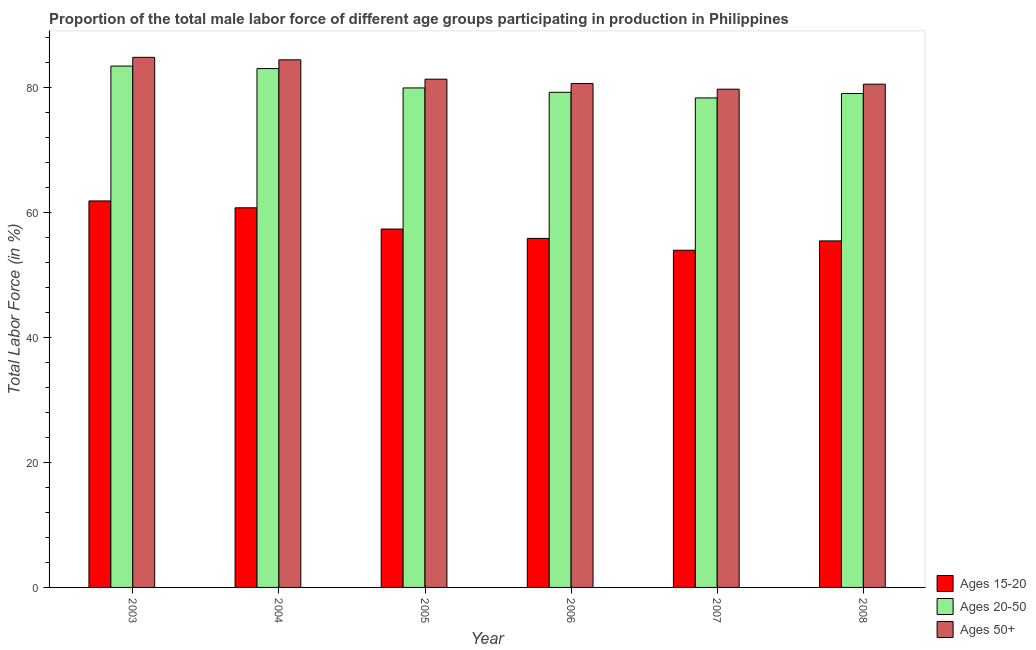How many different coloured bars are there?
Keep it short and to the point. 3. How many groups of bars are there?
Your response must be concise. 6. Are the number of bars on each tick of the X-axis equal?
Keep it short and to the point. Yes. How many bars are there on the 5th tick from the left?
Your response must be concise. 3. What is the label of the 3rd group of bars from the left?
Provide a short and direct response. 2005. In how many cases, is the number of bars for a given year not equal to the number of legend labels?
Give a very brief answer. 0. What is the percentage of male labor force above age 50 in 2007?
Make the answer very short. 79.8. Across all years, what is the maximum percentage of male labor force within the age group 15-20?
Ensure brevity in your answer.  61.9. Across all years, what is the minimum percentage of male labor force within the age group 20-50?
Make the answer very short. 78.4. In which year was the percentage of male labor force within the age group 15-20 maximum?
Offer a terse response. 2003. In which year was the percentage of male labor force above age 50 minimum?
Your answer should be very brief. 2007. What is the total percentage of male labor force within the age group 15-20 in the graph?
Offer a terse response. 345.5. What is the difference between the percentage of male labor force within the age group 15-20 in 2006 and that in 2007?
Your answer should be very brief. 1.9. What is the difference between the percentage of male labor force within the age group 15-20 in 2007 and the percentage of male labor force above age 50 in 2008?
Give a very brief answer. -1.5. What is the average percentage of male labor force within the age group 15-20 per year?
Your answer should be very brief. 57.58. In the year 2004, what is the difference between the percentage of male labor force within the age group 15-20 and percentage of male labor force within the age group 20-50?
Make the answer very short. 0. What is the ratio of the percentage of male labor force within the age group 15-20 in 2003 to that in 2005?
Provide a short and direct response. 1.08. Is the percentage of male labor force above age 50 in 2005 less than that in 2006?
Offer a very short reply. No. What is the difference between the highest and the second highest percentage of male labor force within the age group 15-20?
Your answer should be compact. 1.1. What is the difference between the highest and the lowest percentage of male labor force within the age group 15-20?
Provide a short and direct response. 7.9. Is the sum of the percentage of male labor force within the age group 15-20 in 2004 and 2005 greater than the maximum percentage of male labor force above age 50 across all years?
Your answer should be very brief. Yes. What does the 2nd bar from the left in 2006 represents?
Offer a very short reply. Ages 20-50. What does the 2nd bar from the right in 2007 represents?
Offer a terse response. Ages 20-50. Are all the bars in the graph horizontal?
Provide a short and direct response. No. Are the values on the major ticks of Y-axis written in scientific E-notation?
Offer a very short reply. No. Does the graph contain grids?
Your response must be concise. No. How many legend labels are there?
Give a very brief answer. 3. What is the title of the graph?
Keep it short and to the point. Proportion of the total male labor force of different age groups participating in production in Philippines. Does "Unpaid family workers" appear as one of the legend labels in the graph?
Make the answer very short. No. What is the label or title of the X-axis?
Offer a terse response. Year. What is the label or title of the Y-axis?
Provide a short and direct response. Total Labor Force (in %). What is the Total Labor Force (in %) of Ages 15-20 in 2003?
Your answer should be compact. 61.9. What is the Total Labor Force (in %) in Ages 20-50 in 2003?
Your response must be concise. 83.5. What is the Total Labor Force (in %) in Ages 50+ in 2003?
Keep it short and to the point. 84.9. What is the Total Labor Force (in %) of Ages 15-20 in 2004?
Ensure brevity in your answer.  60.8. What is the Total Labor Force (in %) in Ages 20-50 in 2004?
Keep it short and to the point. 83.1. What is the Total Labor Force (in %) of Ages 50+ in 2004?
Give a very brief answer. 84.5. What is the Total Labor Force (in %) of Ages 15-20 in 2005?
Provide a short and direct response. 57.4. What is the Total Labor Force (in %) of Ages 20-50 in 2005?
Give a very brief answer. 80. What is the Total Labor Force (in %) in Ages 50+ in 2005?
Give a very brief answer. 81.4. What is the Total Labor Force (in %) of Ages 15-20 in 2006?
Provide a short and direct response. 55.9. What is the Total Labor Force (in %) in Ages 20-50 in 2006?
Your answer should be very brief. 79.3. What is the Total Labor Force (in %) of Ages 50+ in 2006?
Your response must be concise. 80.7. What is the Total Labor Force (in %) in Ages 20-50 in 2007?
Keep it short and to the point. 78.4. What is the Total Labor Force (in %) of Ages 50+ in 2007?
Ensure brevity in your answer.  79.8. What is the Total Labor Force (in %) in Ages 15-20 in 2008?
Your answer should be compact. 55.5. What is the Total Labor Force (in %) of Ages 20-50 in 2008?
Give a very brief answer. 79.1. What is the Total Labor Force (in %) in Ages 50+ in 2008?
Give a very brief answer. 80.6. Across all years, what is the maximum Total Labor Force (in %) in Ages 15-20?
Your answer should be very brief. 61.9. Across all years, what is the maximum Total Labor Force (in %) of Ages 20-50?
Keep it short and to the point. 83.5. Across all years, what is the maximum Total Labor Force (in %) in Ages 50+?
Keep it short and to the point. 84.9. Across all years, what is the minimum Total Labor Force (in %) of Ages 20-50?
Offer a terse response. 78.4. Across all years, what is the minimum Total Labor Force (in %) of Ages 50+?
Make the answer very short. 79.8. What is the total Total Labor Force (in %) in Ages 15-20 in the graph?
Your response must be concise. 345.5. What is the total Total Labor Force (in %) in Ages 20-50 in the graph?
Provide a succinct answer. 483.4. What is the total Total Labor Force (in %) in Ages 50+ in the graph?
Offer a very short reply. 491.9. What is the difference between the Total Labor Force (in %) of Ages 50+ in 2003 and that in 2004?
Ensure brevity in your answer.  0.4. What is the difference between the Total Labor Force (in %) of Ages 20-50 in 2003 and that in 2005?
Ensure brevity in your answer.  3.5. What is the difference between the Total Labor Force (in %) of Ages 50+ in 2003 and that in 2005?
Make the answer very short. 3.5. What is the difference between the Total Labor Force (in %) in Ages 15-20 in 2003 and that in 2006?
Give a very brief answer. 6. What is the difference between the Total Labor Force (in %) of Ages 50+ in 2003 and that in 2006?
Your answer should be very brief. 4.2. What is the difference between the Total Labor Force (in %) of Ages 20-50 in 2003 and that in 2007?
Your answer should be very brief. 5.1. What is the difference between the Total Labor Force (in %) in Ages 15-20 in 2003 and that in 2008?
Offer a very short reply. 6.4. What is the difference between the Total Labor Force (in %) in Ages 20-50 in 2004 and that in 2005?
Your answer should be very brief. 3.1. What is the difference between the Total Labor Force (in %) of Ages 15-20 in 2004 and that in 2006?
Make the answer very short. 4.9. What is the difference between the Total Labor Force (in %) in Ages 20-50 in 2004 and that in 2006?
Your answer should be very brief. 3.8. What is the difference between the Total Labor Force (in %) in Ages 50+ in 2004 and that in 2006?
Keep it short and to the point. 3.8. What is the difference between the Total Labor Force (in %) in Ages 15-20 in 2004 and that in 2008?
Ensure brevity in your answer.  5.3. What is the difference between the Total Labor Force (in %) of Ages 20-50 in 2004 and that in 2008?
Provide a short and direct response. 4. What is the difference between the Total Labor Force (in %) in Ages 15-20 in 2005 and that in 2006?
Offer a terse response. 1.5. What is the difference between the Total Labor Force (in %) of Ages 20-50 in 2005 and that in 2006?
Keep it short and to the point. 0.7. What is the difference between the Total Labor Force (in %) in Ages 20-50 in 2005 and that in 2007?
Your answer should be compact. 1.6. What is the difference between the Total Labor Force (in %) of Ages 15-20 in 2005 and that in 2008?
Your answer should be compact. 1.9. What is the difference between the Total Labor Force (in %) in Ages 50+ in 2005 and that in 2008?
Give a very brief answer. 0.8. What is the difference between the Total Labor Force (in %) in Ages 50+ in 2006 and that in 2007?
Make the answer very short. 0.9. What is the difference between the Total Labor Force (in %) in Ages 20-50 in 2006 and that in 2008?
Keep it short and to the point. 0.2. What is the difference between the Total Labor Force (in %) in Ages 50+ in 2006 and that in 2008?
Provide a succinct answer. 0.1. What is the difference between the Total Labor Force (in %) of Ages 50+ in 2007 and that in 2008?
Give a very brief answer. -0.8. What is the difference between the Total Labor Force (in %) of Ages 15-20 in 2003 and the Total Labor Force (in %) of Ages 20-50 in 2004?
Give a very brief answer. -21.2. What is the difference between the Total Labor Force (in %) of Ages 15-20 in 2003 and the Total Labor Force (in %) of Ages 50+ in 2004?
Offer a terse response. -22.6. What is the difference between the Total Labor Force (in %) of Ages 20-50 in 2003 and the Total Labor Force (in %) of Ages 50+ in 2004?
Keep it short and to the point. -1. What is the difference between the Total Labor Force (in %) in Ages 15-20 in 2003 and the Total Labor Force (in %) in Ages 20-50 in 2005?
Make the answer very short. -18.1. What is the difference between the Total Labor Force (in %) of Ages 15-20 in 2003 and the Total Labor Force (in %) of Ages 50+ in 2005?
Ensure brevity in your answer.  -19.5. What is the difference between the Total Labor Force (in %) of Ages 15-20 in 2003 and the Total Labor Force (in %) of Ages 20-50 in 2006?
Ensure brevity in your answer.  -17.4. What is the difference between the Total Labor Force (in %) in Ages 15-20 in 2003 and the Total Labor Force (in %) in Ages 50+ in 2006?
Your answer should be compact. -18.8. What is the difference between the Total Labor Force (in %) of Ages 15-20 in 2003 and the Total Labor Force (in %) of Ages 20-50 in 2007?
Your answer should be very brief. -16.5. What is the difference between the Total Labor Force (in %) of Ages 15-20 in 2003 and the Total Labor Force (in %) of Ages 50+ in 2007?
Your answer should be compact. -17.9. What is the difference between the Total Labor Force (in %) of Ages 20-50 in 2003 and the Total Labor Force (in %) of Ages 50+ in 2007?
Give a very brief answer. 3.7. What is the difference between the Total Labor Force (in %) in Ages 15-20 in 2003 and the Total Labor Force (in %) in Ages 20-50 in 2008?
Give a very brief answer. -17.2. What is the difference between the Total Labor Force (in %) of Ages 15-20 in 2003 and the Total Labor Force (in %) of Ages 50+ in 2008?
Offer a very short reply. -18.7. What is the difference between the Total Labor Force (in %) in Ages 15-20 in 2004 and the Total Labor Force (in %) in Ages 20-50 in 2005?
Offer a terse response. -19.2. What is the difference between the Total Labor Force (in %) of Ages 15-20 in 2004 and the Total Labor Force (in %) of Ages 50+ in 2005?
Provide a short and direct response. -20.6. What is the difference between the Total Labor Force (in %) in Ages 20-50 in 2004 and the Total Labor Force (in %) in Ages 50+ in 2005?
Your answer should be very brief. 1.7. What is the difference between the Total Labor Force (in %) in Ages 15-20 in 2004 and the Total Labor Force (in %) in Ages 20-50 in 2006?
Keep it short and to the point. -18.5. What is the difference between the Total Labor Force (in %) of Ages 15-20 in 2004 and the Total Labor Force (in %) of Ages 50+ in 2006?
Offer a terse response. -19.9. What is the difference between the Total Labor Force (in %) of Ages 15-20 in 2004 and the Total Labor Force (in %) of Ages 20-50 in 2007?
Offer a terse response. -17.6. What is the difference between the Total Labor Force (in %) in Ages 20-50 in 2004 and the Total Labor Force (in %) in Ages 50+ in 2007?
Keep it short and to the point. 3.3. What is the difference between the Total Labor Force (in %) in Ages 15-20 in 2004 and the Total Labor Force (in %) in Ages 20-50 in 2008?
Provide a short and direct response. -18.3. What is the difference between the Total Labor Force (in %) of Ages 15-20 in 2004 and the Total Labor Force (in %) of Ages 50+ in 2008?
Offer a terse response. -19.8. What is the difference between the Total Labor Force (in %) of Ages 20-50 in 2004 and the Total Labor Force (in %) of Ages 50+ in 2008?
Give a very brief answer. 2.5. What is the difference between the Total Labor Force (in %) of Ages 15-20 in 2005 and the Total Labor Force (in %) of Ages 20-50 in 2006?
Offer a terse response. -21.9. What is the difference between the Total Labor Force (in %) of Ages 15-20 in 2005 and the Total Labor Force (in %) of Ages 50+ in 2006?
Your answer should be very brief. -23.3. What is the difference between the Total Labor Force (in %) of Ages 15-20 in 2005 and the Total Labor Force (in %) of Ages 50+ in 2007?
Provide a succinct answer. -22.4. What is the difference between the Total Labor Force (in %) of Ages 20-50 in 2005 and the Total Labor Force (in %) of Ages 50+ in 2007?
Ensure brevity in your answer.  0.2. What is the difference between the Total Labor Force (in %) in Ages 15-20 in 2005 and the Total Labor Force (in %) in Ages 20-50 in 2008?
Provide a succinct answer. -21.7. What is the difference between the Total Labor Force (in %) in Ages 15-20 in 2005 and the Total Labor Force (in %) in Ages 50+ in 2008?
Offer a terse response. -23.2. What is the difference between the Total Labor Force (in %) of Ages 15-20 in 2006 and the Total Labor Force (in %) of Ages 20-50 in 2007?
Provide a short and direct response. -22.5. What is the difference between the Total Labor Force (in %) in Ages 15-20 in 2006 and the Total Labor Force (in %) in Ages 50+ in 2007?
Make the answer very short. -23.9. What is the difference between the Total Labor Force (in %) in Ages 15-20 in 2006 and the Total Labor Force (in %) in Ages 20-50 in 2008?
Offer a terse response. -23.2. What is the difference between the Total Labor Force (in %) of Ages 15-20 in 2006 and the Total Labor Force (in %) of Ages 50+ in 2008?
Your answer should be very brief. -24.7. What is the difference between the Total Labor Force (in %) of Ages 15-20 in 2007 and the Total Labor Force (in %) of Ages 20-50 in 2008?
Keep it short and to the point. -25.1. What is the difference between the Total Labor Force (in %) in Ages 15-20 in 2007 and the Total Labor Force (in %) in Ages 50+ in 2008?
Make the answer very short. -26.6. What is the average Total Labor Force (in %) of Ages 15-20 per year?
Your response must be concise. 57.58. What is the average Total Labor Force (in %) in Ages 20-50 per year?
Give a very brief answer. 80.57. What is the average Total Labor Force (in %) of Ages 50+ per year?
Your answer should be very brief. 81.98. In the year 2003, what is the difference between the Total Labor Force (in %) of Ages 15-20 and Total Labor Force (in %) of Ages 20-50?
Your response must be concise. -21.6. In the year 2003, what is the difference between the Total Labor Force (in %) in Ages 20-50 and Total Labor Force (in %) in Ages 50+?
Your answer should be compact. -1.4. In the year 2004, what is the difference between the Total Labor Force (in %) of Ages 15-20 and Total Labor Force (in %) of Ages 20-50?
Provide a succinct answer. -22.3. In the year 2004, what is the difference between the Total Labor Force (in %) in Ages 15-20 and Total Labor Force (in %) in Ages 50+?
Make the answer very short. -23.7. In the year 2005, what is the difference between the Total Labor Force (in %) of Ages 15-20 and Total Labor Force (in %) of Ages 20-50?
Your answer should be compact. -22.6. In the year 2005, what is the difference between the Total Labor Force (in %) of Ages 15-20 and Total Labor Force (in %) of Ages 50+?
Provide a succinct answer. -24. In the year 2006, what is the difference between the Total Labor Force (in %) of Ages 15-20 and Total Labor Force (in %) of Ages 20-50?
Ensure brevity in your answer.  -23.4. In the year 2006, what is the difference between the Total Labor Force (in %) of Ages 15-20 and Total Labor Force (in %) of Ages 50+?
Make the answer very short. -24.8. In the year 2006, what is the difference between the Total Labor Force (in %) of Ages 20-50 and Total Labor Force (in %) of Ages 50+?
Offer a terse response. -1.4. In the year 2007, what is the difference between the Total Labor Force (in %) in Ages 15-20 and Total Labor Force (in %) in Ages 20-50?
Offer a very short reply. -24.4. In the year 2007, what is the difference between the Total Labor Force (in %) in Ages 15-20 and Total Labor Force (in %) in Ages 50+?
Your response must be concise. -25.8. In the year 2008, what is the difference between the Total Labor Force (in %) in Ages 15-20 and Total Labor Force (in %) in Ages 20-50?
Give a very brief answer. -23.6. In the year 2008, what is the difference between the Total Labor Force (in %) in Ages 15-20 and Total Labor Force (in %) in Ages 50+?
Your response must be concise. -25.1. In the year 2008, what is the difference between the Total Labor Force (in %) of Ages 20-50 and Total Labor Force (in %) of Ages 50+?
Ensure brevity in your answer.  -1.5. What is the ratio of the Total Labor Force (in %) of Ages 15-20 in 2003 to that in 2004?
Your response must be concise. 1.02. What is the ratio of the Total Labor Force (in %) of Ages 20-50 in 2003 to that in 2004?
Keep it short and to the point. 1. What is the ratio of the Total Labor Force (in %) of Ages 15-20 in 2003 to that in 2005?
Provide a succinct answer. 1.08. What is the ratio of the Total Labor Force (in %) in Ages 20-50 in 2003 to that in 2005?
Keep it short and to the point. 1.04. What is the ratio of the Total Labor Force (in %) of Ages 50+ in 2003 to that in 2005?
Your answer should be compact. 1.04. What is the ratio of the Total Labor Force (in %) in Ages 15-20 in 2003 to that in 2006?
Offer a very short reply. 1.11. What is the ratio of the Total Labor Force (in %) of Ages 20-50 in 2003 to that in 2006?
Offer a very short reply. 1.05. What is the ratio of the Total Labor Force (in %) in Ages 50+ in 2003 to that in 2006?
Offer a terse response. 1.05. What is the ratio of the Total Labor Force (in %) of Ages 15-20 in 2003 to that in 2007?
Ensure brevity in your answer.  1.15. What is the ratio of the Total Labor Force (in %) of Ages 20-50 in 2003 to that in 2007?
Provide a short and direct response. 1.07. What is the ratio of the Total Labor Force (in %) of Ages 50+ in 2003 to that in 2007?
Ensure brevity in your answer.  1.06. What is the ratio of the Total Labor Force (in %) in Ages 15-20 in 2003 to that in 2008?
Offer a very short reply. 1.12. What is the ratio of the Total Labor Force (in %) of Ages 20-50 in 2003 to that in 2008?
Your answer should be compact. 1.06. What is the ratio of the Total Labor Force (in %) of Ages 50+ in 2003 to that in 2008?
Keep it short and to the point. 1.05. What is the ratio of the Total Labor Force (in %) in Ages 15-20 in 2004 to that in 2005?
Your answer should be very brief. 1.06. What is the ratio of the Total Labor Force (in %) of Ages 20-50 in 2004 to that in 2005?
Your answer should be very brief. 1.04. What is the ratio of the Total Labor Force (in %) in Ages 50+ in 2004 to that in 2005?
Give a very brief answer. 1.04. What is the ratio of the Total Labor Force (in %) of Ages 15-20 in 2004 to that in 2006?
Your answer should be very brief. 1.09. What is the ratio of the Total Labor Force (in %) of Ages 20-50 in 2004 to that in 2006?
Offer a terse response. 1.05. What is the ratio of the Total Labor Force (in %) of Ages 50+ in 2004 to that in 2006?
Keep it short and to the point. 1.05. What is the ratio of the Total Labor Force (in %) in Ages 15-20 in 2004 to that in 2007?
Ensure brevity in your answer.  1.13. What is the ratio of the Total Labor Force (in %) in Ages 20-50 in 2004 to that in 2007?
Your response must be concise. 1.06. What is the ratio of the Total Labor Force (in %) of Ages 50+ in 2004 to that in 2007?
Your response must be concise. 1.06. What is the ratio of the Total Labor Force (in %) of Ages 15-20 in 2004 to that in 2008?
Ensure brevity in your answer.  1.1. What is the ratio of the Total Labor Force (in %) of Ages 20-50 in 2004 to that in 2008?
Provide a short and direct response. 1.05. What is the ratio of the Total Labor Force (in %) in Ages 50+ in 2004 to that in 2008?
Offer a very short reply. 1.05. What is the ratio of the Total Labor Force (in %) of Ages 15-20 in 2005 to that in 2006?
Offer a very short reply. 1.03. What is the ratio of the Total Labor Force (in %) in Ages 20-50 in 2005 to that in 2006?
Ensure brevity in your answer.  1.01. What is the ratio of the Total Labor Force (in %) of Ages 50+ in 2005 to that in 2006?
Provide a short and direct response. 1.01. What is the ratio of the Total Labor Force (in %) of Ages 15-20 in 2005 to that in 2007?
Offer a terse response. 1.06. What is the ratio of the Total Labor Force (in %) in Ages 20-50 in 2005 to that in 2007?
Offer a very short reply. 1.02. What is the ratio of the Total Labor Force (in %) in Ages 50+ in 2005 to that in 2007?
Ensure brevity in your answer.  1.02. What is the ratio of the Total Labor Force (in %) of Ages 15-20 in 2005 to that in 2008?
Make the answer very short. 1.03. What is the ratio of the Total Labor Force (in %) in Ages 20-50 in 2005 to that in 2008?
Your answer should be compact. 1.01. What is the ratio of the Total Labor Force (in %) of Ages 50+ in 2005 to that in 2008?
Offer a very short reply. 1.01. What is the ratio of the Total Labor Force (in %) of Ages 15-20 in 2006 to that in 2007?
Offer a very short reply. 1.04. What is the ratio of the Total Labor Force (in %) of Ages 20-50 in 2006 to that in 2007?
Give a very brief answer. 1.01. What is the ratio of the Total Labor Force (in %) of Ages 50+ in 2006 to that in 2007?
Your answer should be compact. 1.01. What is the ratio of the Total Labor Force (in %) of Ages 15-20 in 2006 to that in 2008?
Ensure brevity in your answer.  1.01. What is the ratio of the Total Labor Force (in %) of Ages 20-50 in 2006 to that in 2008?
Keep it short and to the point. 1. What is the ratio of the Total Labor Force (in %) of Ages 15-20 in 2007 to that in 2008?
Offer a terse response. 0.97. What is the ratio of the Total Labor Force (in %) in Ages 20-50 in 2007 to that in 2008?
Provide a short and direct response. 0.99. What is the difference between the highest and the second highest Total Labor Force (in %) of Ages 15-20?
Provide a short and direct response. 1.1. What is the difference between the highest and the second highest Total Labor Force (in %) in Ages 20-50?
Ensure brevity in your answer.  0.4. What is the difference between the highest and the second highest Total Labor Force (in %) in Ages 50+?
Offer a terse response. 0.4. 